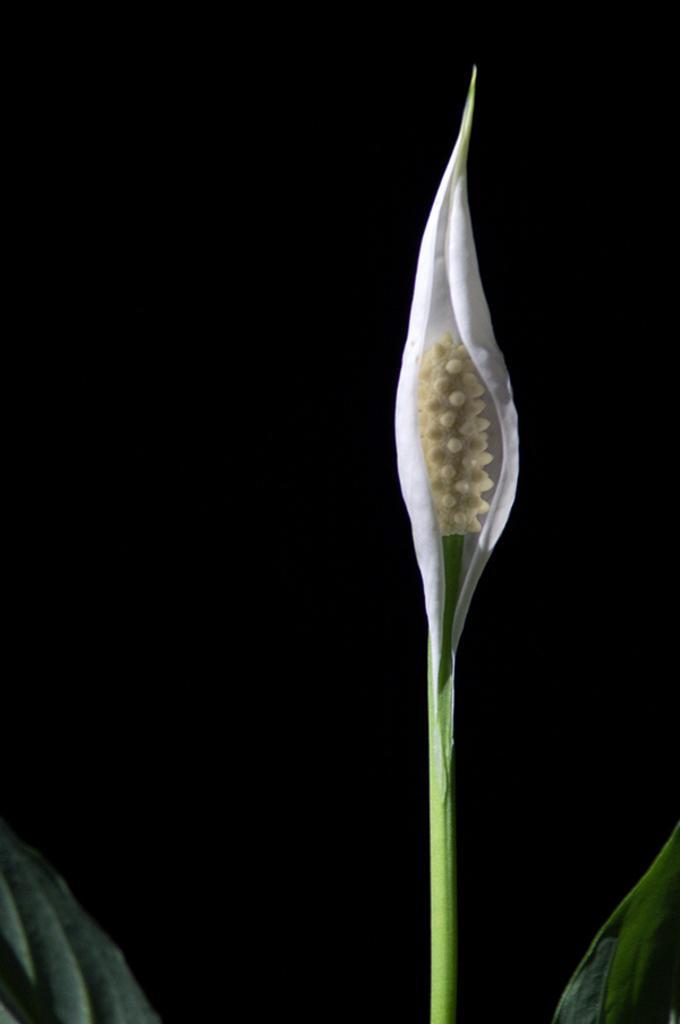Describe this image in one or two sentences. In this image I can see a flower which is in cream and white color and few green leaves. Background is in black color. 